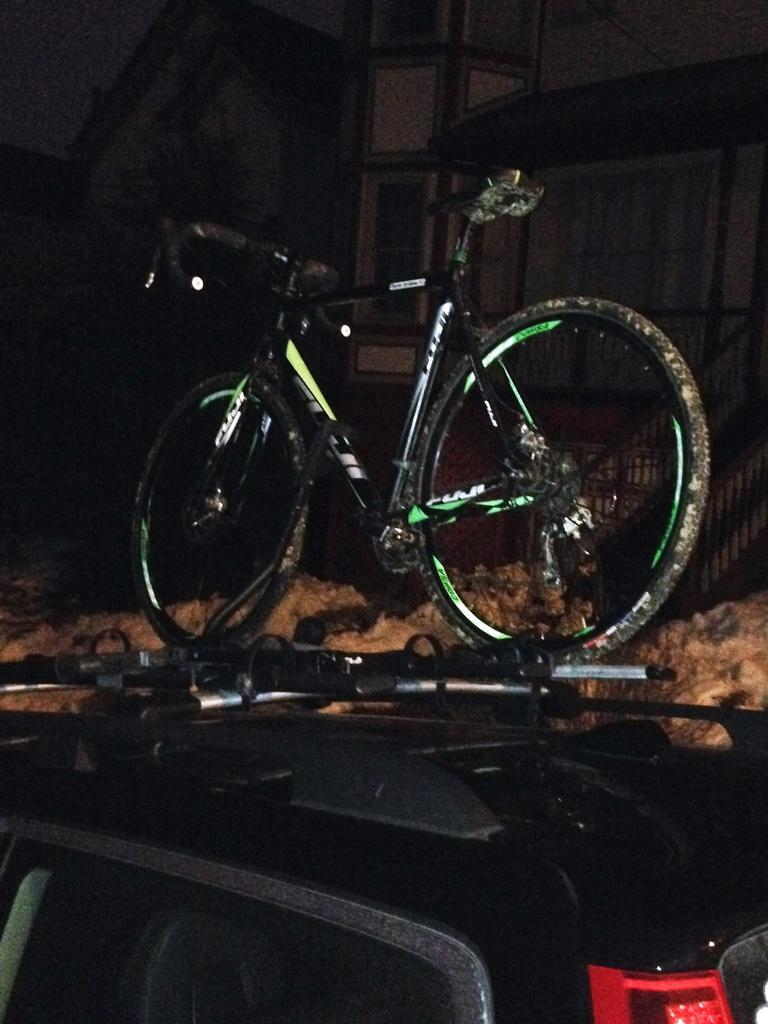What is the main object in the image? There is a bicycle in the image. Where is the bicycle located? The bicycle is on a black color car. What can be seen in the background of the image? There are houses in the background of the image. What invention is being demonstrated in the image? There is no invention being demonstrated in the image; it simply shows a bicycle on a black color car with houses in the background. 